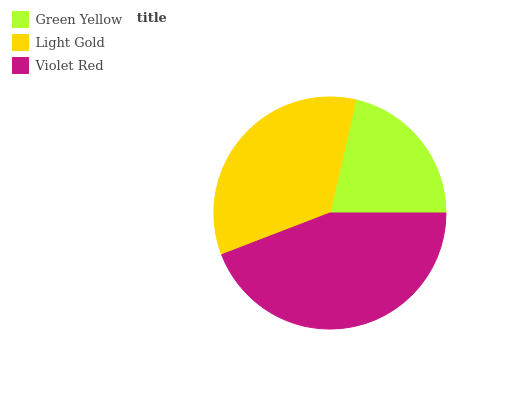Is Green Yellow the minimum?
Answer yes or no. Yes. Is Violet Red the maximum?
Answer yes or no. Yes. Is Light Gold the minimum?
Answer yes or no. No. Is Light Gold the maximum?
Answer yes or no. No. Is Light Gold greater than Green Yellow?
Answer yes or no. Yes. Is Green Yellow less than Light Gold?
Answer yes or no. Yes. Is Green Yellow greater than Light Gold?
Answer yes or no. No. Is Light Gold less than Green Yellow?
Answer yes or no. No. Is Light Gold the high median?
Answer yes or no. Yes. Is Light Gold the low median?
Answer yes or no. Yes. Is Violet Red the high median?
Answer yes or no. No. Is Violet Red the low median?
Answer yes or no. No. 